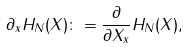<formula> <loc_0><loc_0><loc_500><loc_500>\partial _ { x } H _ { N } ( X ) \colon = \frac { \partial } { \partial X _ { x } } H _ { N } ( X ) ,</formula> 